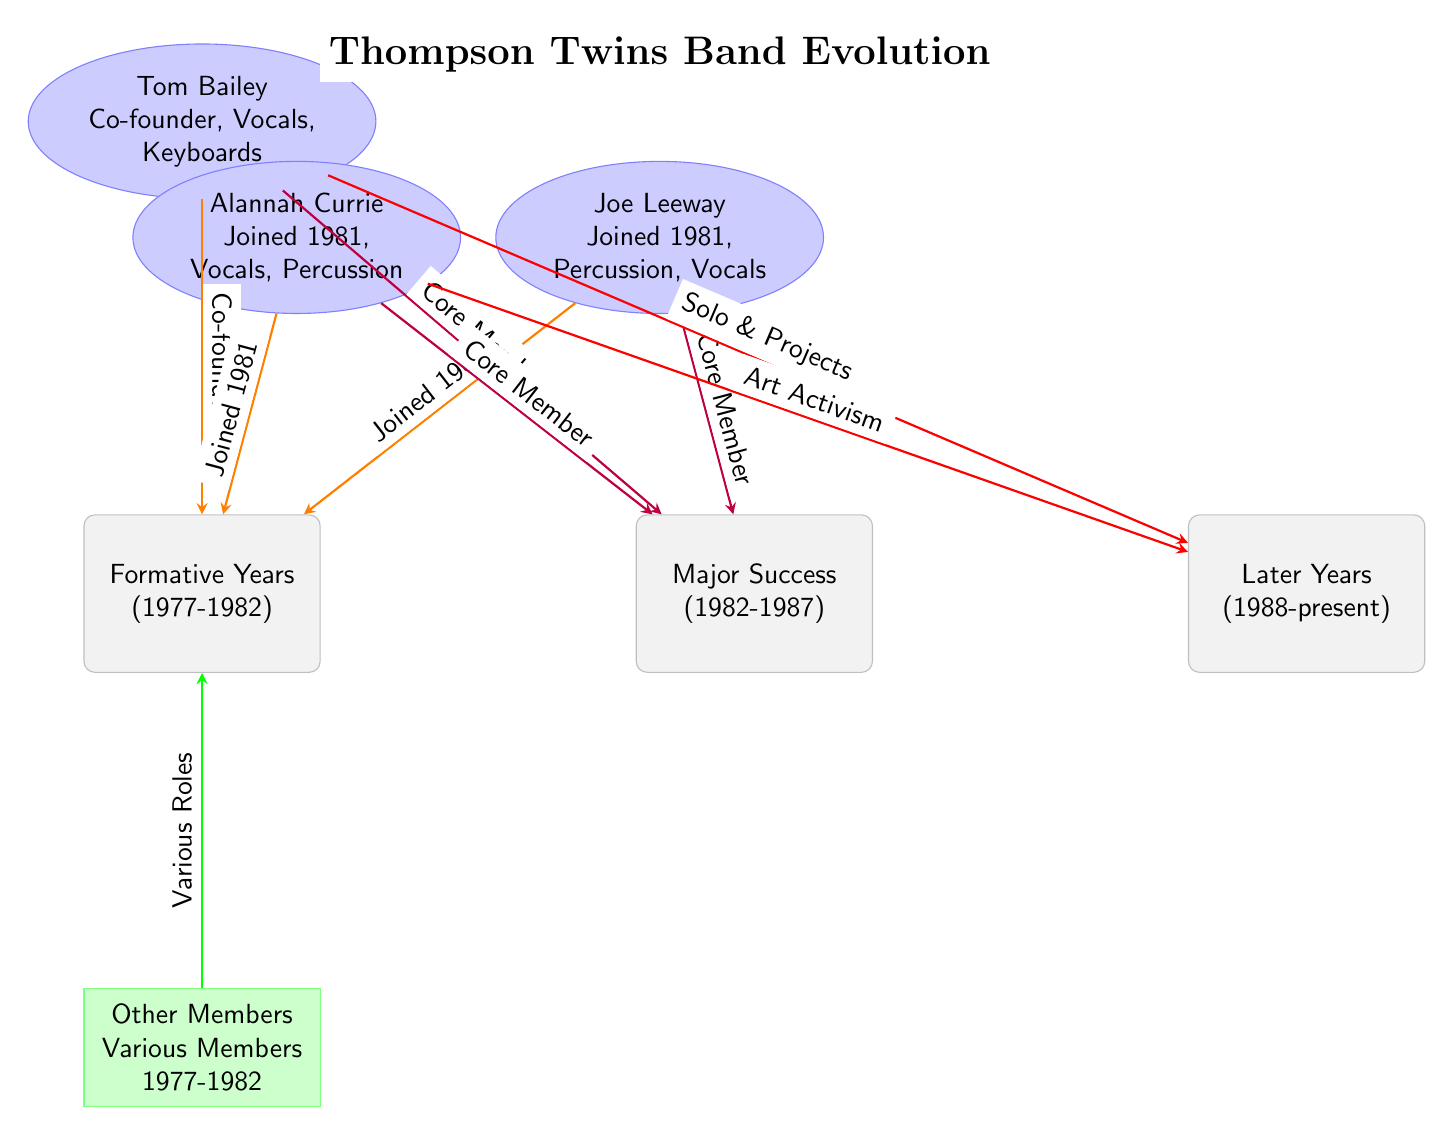What years are marked as the "Formative Years"? The "Formative Years" are indicated in the diagram as spanning from 1977 to 1982. This information is directly stated in the timeline node for the formative years.
Answer: 1977-1982 How many core members joined the band during the formative years? The diagram shows three members: Tom Bailey, Joe Leeway, and Alannah Currie who became core members during the "Major Success" period which follows the formative years. Thus, we can count these three members related to the formative years.
Answer: 3 What role did Tom Bailey have in the band? The diagram specifies that Tom Bailey is the "Co-founder" of the band and also mentions his roles as "Vocals" and "Keyboards" in the node about him. This succinctly describes his position in the band.
Answer: Co-founder, Vocals, Keyboards Which member focused on "Art Activism" in later years? The diagram identifies Alannah Currie as the member associated with "Art Activism" in the later years section of the diagram, indicating this specific direction she took.
Answer: Alannah Currie What type of relationships link the members to the "Major Success" node? In the diagram, the members are linked to the "Major Success" node through the "Core Member" relationship, indicating their central role during that successful phase of the band. Each of the members is specifically labeled with this relationship in this section.
Answer: Core Member Which two members joined in 1981? According to the diagram, both Joe Leeway and Alannah Currie are noted with "Joined 1981," indicating they became part of the band during that year. This can be found beside their names linked to the formative years.
Answer: Joe Leeway, Alannah Currie What is described in the "Other Members" box? The "Other Members" box describes "Various Members" during the years of 1977 to 1982, highlighting that there were other individuals involved in the band during the formative years aside from the core members listed.
Answer: Various Members What kind of projects did Tom pursue in the later years? The diagram states that Tom Bailey is indicated with the path related to "Solo & Projects" in the later years, showing his direction towards independent work outside of the band setting.
Answer: Solo & Projects How is Alannah Currie related to the "Major Success" node? Alannah Currie is depicted as a "Core Member" who played a significant role during the "Major Success" period, connecting her directly to that timeline node through her contributions in the band.
Answer: Core Member 